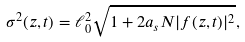<formula> <loc_0><loc_0><loc_500><loc_500>\sigma ^ { 2 } ( z , t ) = \ell _ { 0 } ^ { 2 } \sqrt { 1 + 2 a _ { s } N | f ( z , t ) | ^ { 2 } } ,</formula> 